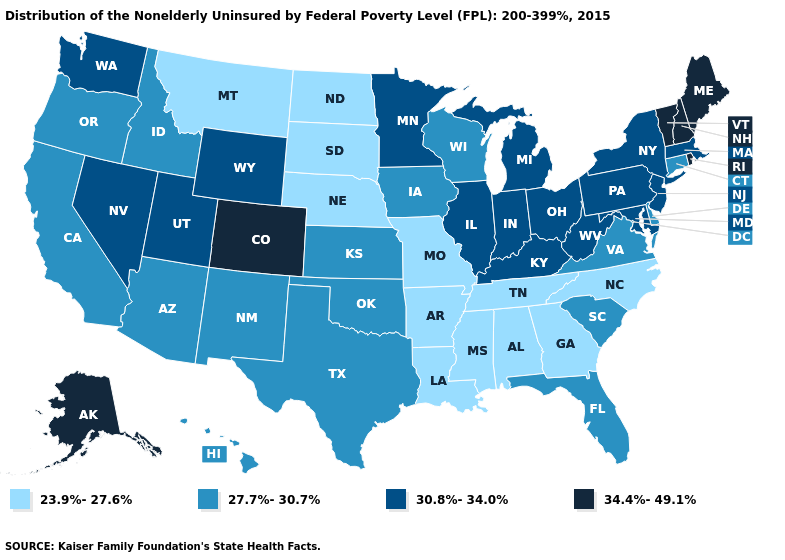Does Tennessee have the lowest value in the USA?
Concise answer only. Yes. What is the value of Maine?
Concise answer only. 34.4%-49.1%. What is the highest value in the West ?
Write a very short answer. 34.4%-49.1%. Does the map have missing data?
Concise answer only. No. Does Ohio have the highest value in the MidWest?
Concise answer only. Yes. What is the highest value in the USA?
Answer briefly. 34.4%-49.1%. Name the states that have a value in the range 30.8%-34.0%?
Answer briefly. Illinois, Indiana, Kentucky, Maryland, Massachusetts, Michigan, Minnesota, Nevada, New Jersey, New York, Ohio, Pennsylvania, Utah, Washington, West Virginia, Wyoming. What is the value of Massachusetts?
Give a very brief answer. 30.8%-34.0%. Does Maryland have the same value as Illinois?
Give a very brief answer. Yes. Name the states that have a value in the range 30.8%-34.0%?
Give a very brief answer. Illinois, Indiana, Kentucky, Maryland, Massachusetts, Michigan, Minnesota, Nevada, New Jersey, New York, Ohio, Pennsylvania, Utah, Washington, West Virginia, Wyoming. What is the highest value in the West ?
Answer briefly. 34.4%-49.1%. Name the states that have a value in the range 23.9%-27.6%?
Be succinct. Alabama, Arkansas, Georgia, Louisiana, Mississippi, Missouri, Montana, Nebraska, North Carolina, North Dakota, South Dakota, Tennessee. What is the lowest value in states that border Kansas?
Concise answer only. 23.9%-27.6%. Name the states that have a value in the range 34.4%-49.1%?
Quick response, please. Alaska, Colorado, Maine, New Hampshire, Rhode Island, Vermont. Does the first symbol in the legend represent the smallest category?
Quick response, please. Yes. 